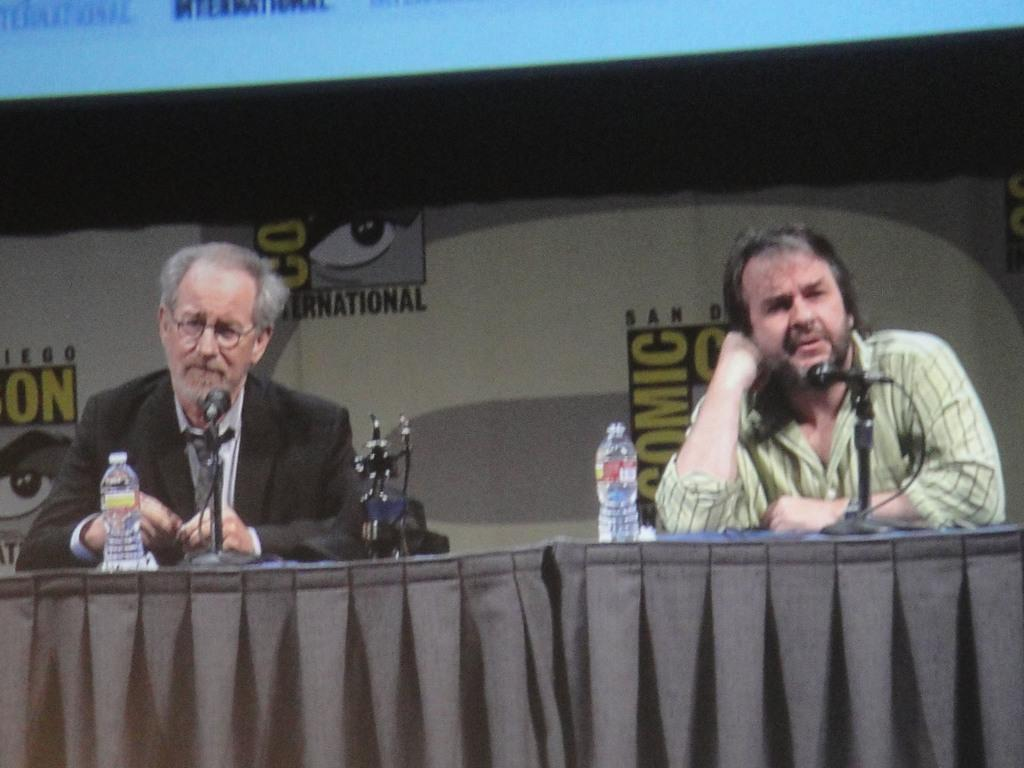What is present in the image that serves as a background? There is a wall in the image that serves as a background. What are the two people in the image doing? The two people in the image are sitting on chairs. What piece of furniture is present in the image that can be used for placing objects? There is a table in the image that can be used for placing objects. What type of animals can be seen on the table? There are mice on the table. What else can be seen on the table besides the mice? There are bottles on the table. What type of harmony is being played by the band in the image? There is no band present in the image, so there is no harmony being played. What type of jelly is being served on the table in the image? There is no jelly present in the image; it features mice and bottles on the table. 